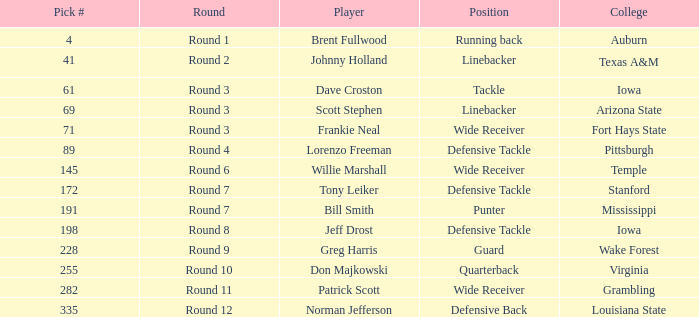Which college had Tony Leiker in round 7? Stanford. 